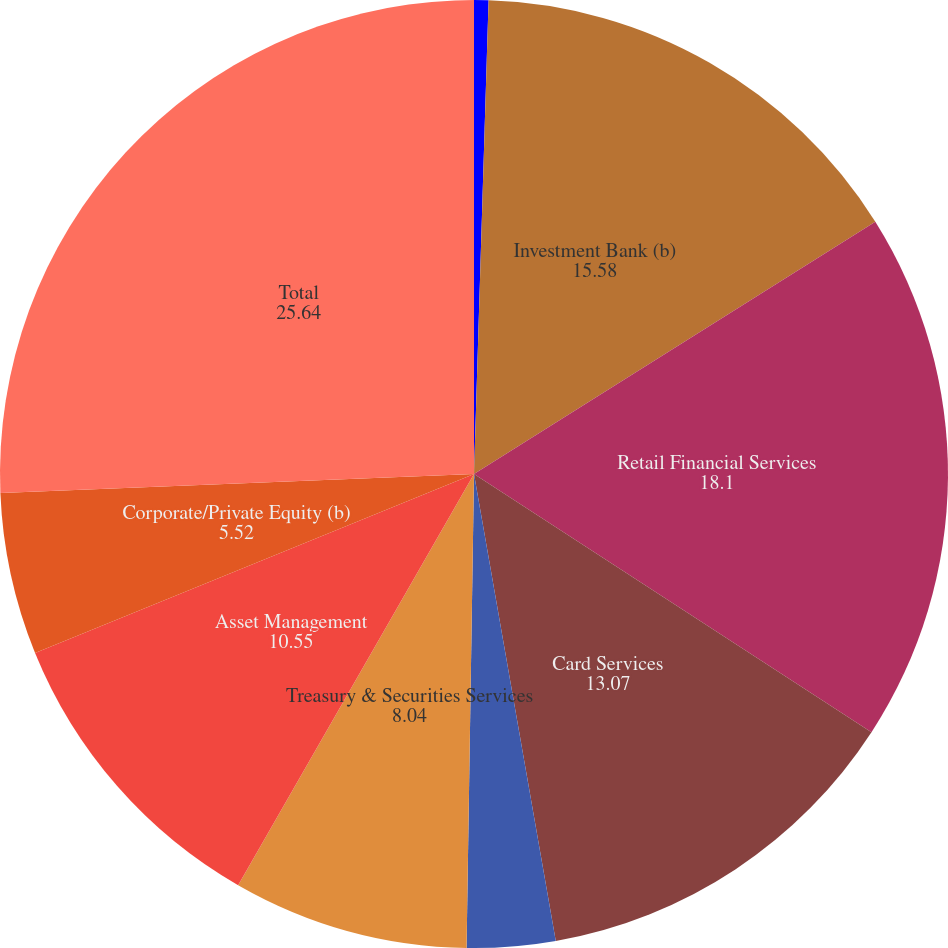Convert chart to OTSL. <chart><loc_0><loc_0><loc_500><loc_500><pie_chart><fcel>(in millions)<fcel>Investment Bank (b)<fcel>Retail Financial Services<fcel>Card Services<fcel>Commercial Banking<fcel>Treasury & Securities Services<fcel>Asset Management<fcel>Corporate/Private Equity (b)<fcel>Total<nl><fcel>0.49%<fcel>15.58%<fcel>18.1%<fcel>13.07%<fcel>3.01%<fcel>8.04%<fcel>10.55%<fcel>5.52%<fcel>25.64%<nl></chart> 